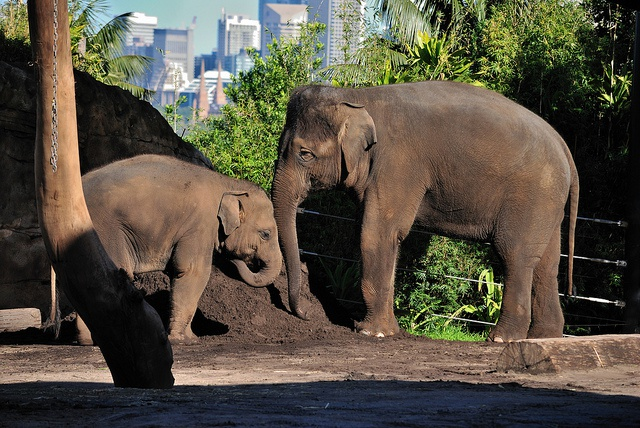Describe the objects in this image and their specific colors. I can see elephant in lightblue, gray, maroon, and black tones and elephant in lightblue, gray, tan, and black tones in this image. 